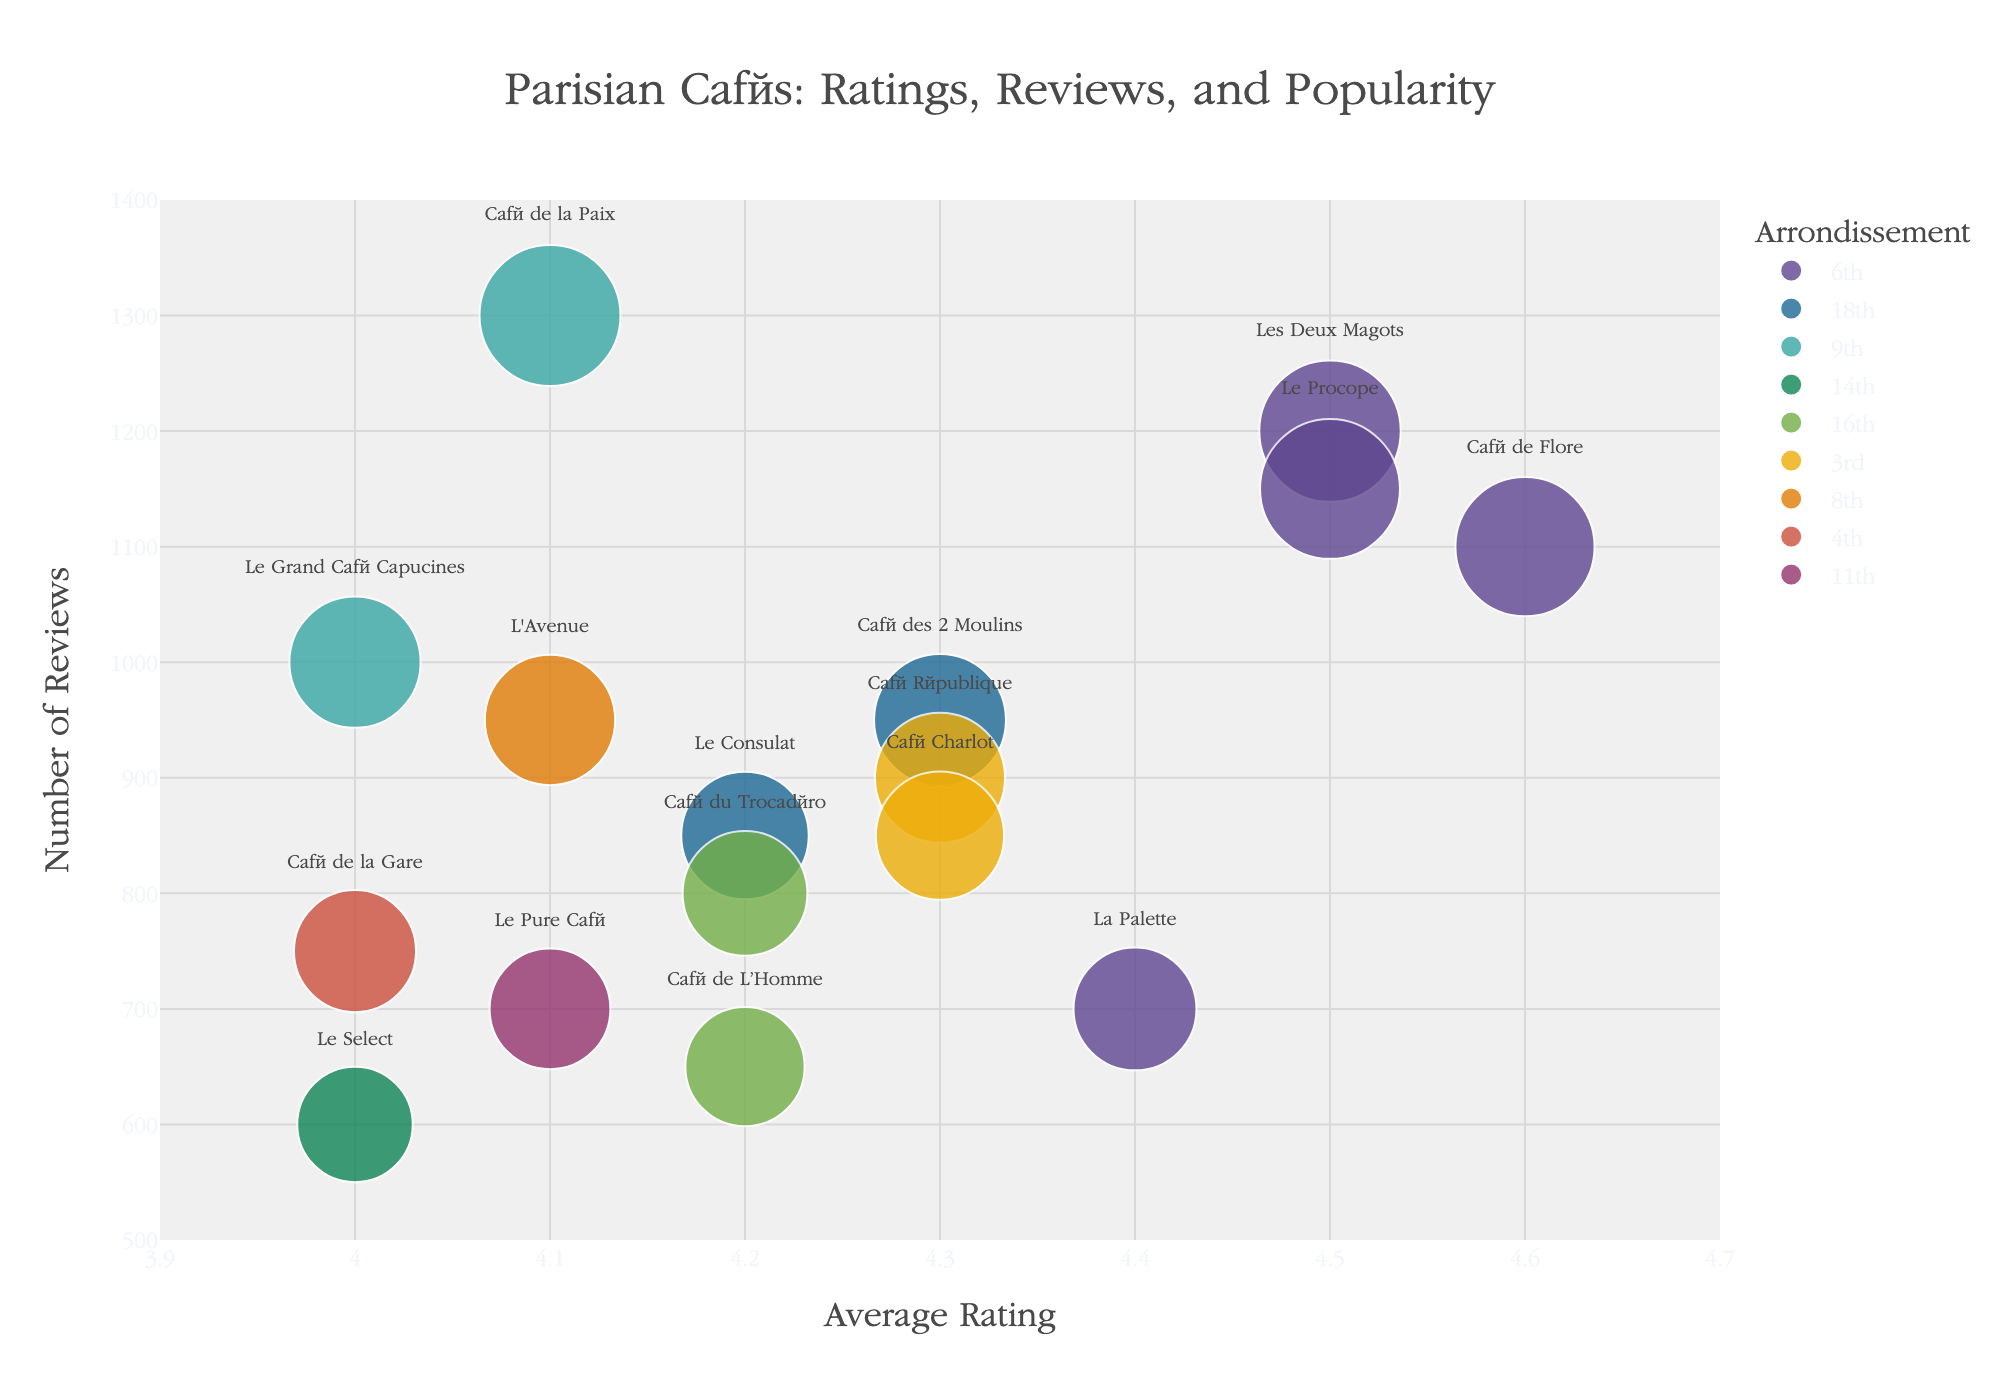what is the title of the figure? The title is usually located at the top of the figure. This one is centered and reads "Parisian Cafés: Ratings, Reviews, and Popularity"
Answer: Parisian Cafés: Ratings, Reviews, and Popularity How many cafes from the 6th arrondissement are shown in the figure? Identify the unique cafés in the 6th arrondissement by their color. The provided data lists five cafés: Les Deux Magots, Café de Flore, La Palette, Le Procope
Answer: 5 Which café has the highest number of reviews? By comparing the y-values of all data points, the point furthest up on the y-axis represents the café with the highest number of reviews. Café de la Paix has 1300 reviews.
Answer: Café de la Paix Which arrondissement has the café with the highest average rating? Checking the x-coordinate values for each arrondissement, Café de Flore from the 6th arrondissement has the highest average rating of 4.6 out of all cafés.
Answer: 6th Which café has the highest popularity score? By comparing the sizes of all the bubbles, the largest bubble represents the café with the highest popularity score. Les Deux Magots has a significant size corresponding to a 5400 popularity score.
Answer: Les Deux Magots Compare the number of reviews of Café de Flore and Les Deux Magots. Which has more? Checking the y-axis values for both cafés, Les Deux Magots has 1200 reviews while Café de Flore has 1100 reviews.
Answer: Les Deux Magots What's the difference in popularity score between Café des 2 Moulins and Le Consulat? Looking at the size of the two bubbles and referring to the data, Café des 2 Moulins has a popularity score of 4085 and Le Consulat has 3570. Calculate the difference: 4085 - 3570 = 515.
Answer: 515 Which café in the 16th arrondissement has a higher average rating: Café du Trocadéro or Café de L’Homme? Examine the x-values associated with each café. Café du Trocadéro has a rating of 4.2, while Café de L’Homme also has a rating of 4.2. Since the values are identical, neither café has a higher rating.
Answer: Draw Which arrondissement has the most cafés listed in this figure? By counting the number of cafes for each arrondissement, the 6th arrondissement has the most, with five cafés.
Answer: 6th What's the average rating of cafés in the 3rd arrondissement? Identify and list the ratings of all cafés in the 3rd arrondissement: Café République (4.3) and Café Charlot (4.3). Calculate the average: (4.3 + 4.3) / 2 = 4.3.
Answer: 4.3 